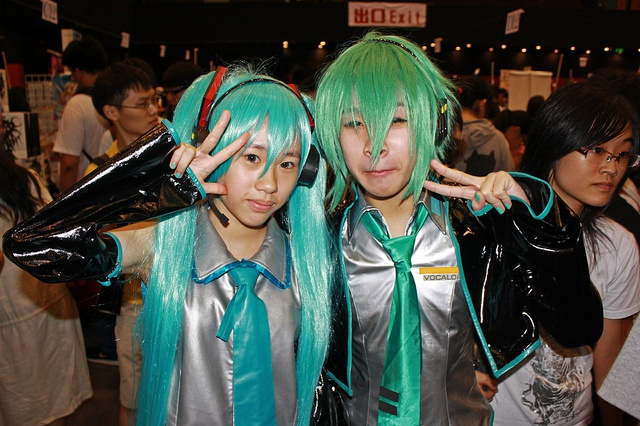Describe the objects in this image and their specific colors. I can see people in black, teal, darkgray, and gray tones, people in black, gray, green, and teal tones, people in black, darkgray, maroon, and gray tones, people in black, maroon, and gray tones, and tie in black, teal, and turquoise tones in this image. 